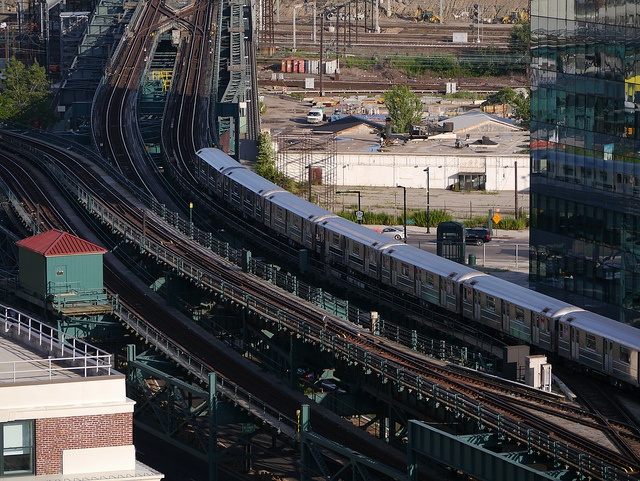Describe the objects in this image and their specific colors. I can see train in gray and black tones, car in gray, black, and darkblue tones, car in gray, darkgray, lightgray, and black tones, car in gray, lightgray, darkgray, and black tones, and truck in gray, lightgray, darkgray, and black tones in this image. 